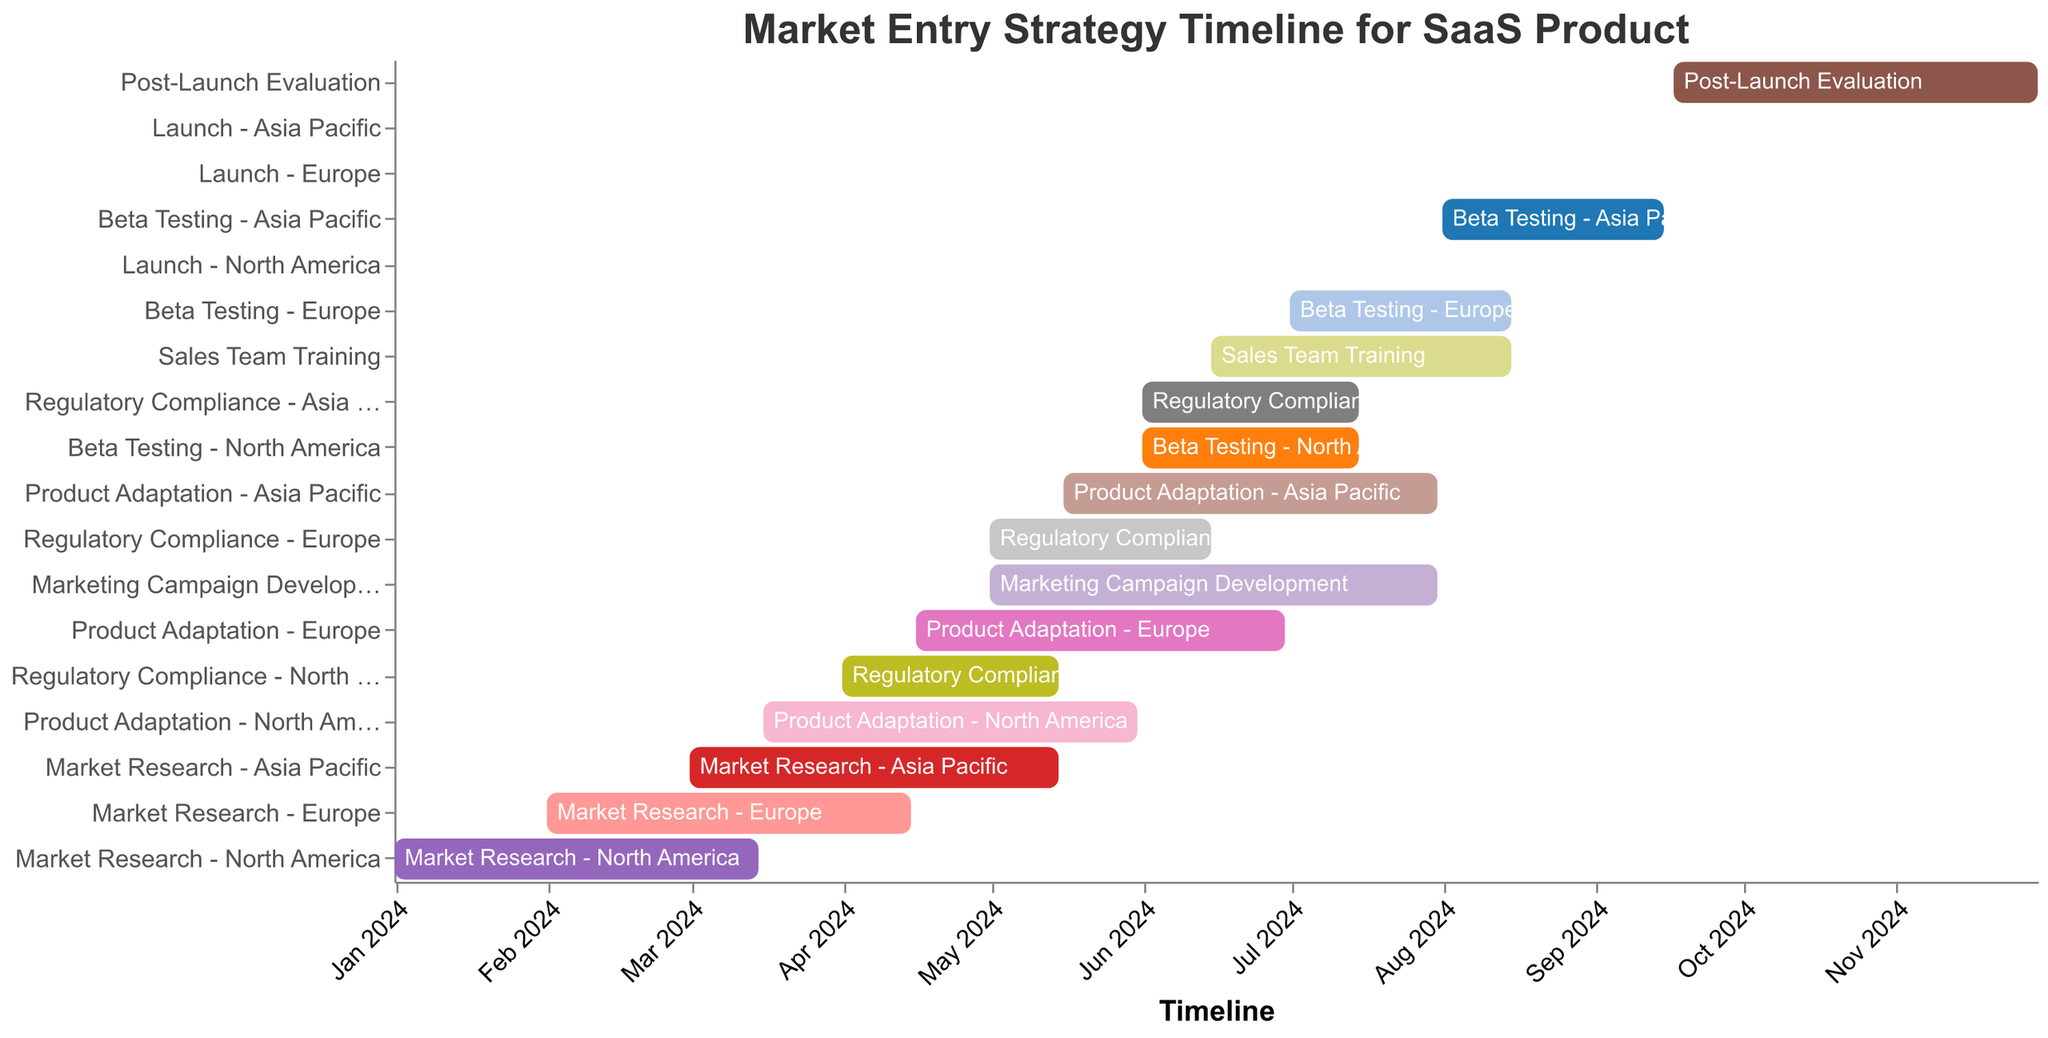What is the title of the Gantt Chart? The title is located at the top of the chart and provides a brief description of what the chart is about.
Answer: Market Entry Strategy Timeline for SaaS Product Which phase starts first in the timeline? To determine which phase starts first, look for the earliest "Start Date" on the timeline.
Answer: Market Research - North America How long does the "Product Adaptation - North America" phase last? Subtract the "Start Date" from the "End Date" for the "Product Adaptation - North America" task to calculate its duration. A simple date difference calculation will provide the duration.
Answer: 76 days Which market completes its "Beta Testing" phase last? Compare the "End Date" of the "Beta Testing" phase for North America, Europe, and Asia Pacific. The market with the latest "End Date" finishes last.
Answer: Asia Pacific During which month does the "Sales Team Training" start? Check the "Start Date" of the "Sales Team Training" task to identify the starting month.
Answer: June 2024 What task is executed immediately after "Marketing Campaign Development"? Look at the "End Date" of "Marketing Campaign Development" and identify the next task that starts after this date.
Answer: Sales Team Training Which country has its "Product Adaptation" phase overlap with its "Regulatory Compliance" phase? Identify the countries with overlapping dates by comparing the start and end dates of their "Product Adaptation" and "Regulatory Compliance" phases.
Answer: North America For how many months does the "Post-Launch Evaluation" phase run? Calculate the time span between the "Start Date" and "End Date" for the "Post-Launch Evaluation" phase, then convert the duration into months.
Answer: 2.5 months What are the total number of tasks listed in the Gantt Chart? Count the number of unique tasks listed on the Y-axis of the chart.
Answer: 18 tasks Which phase is the last in the timeline? Look for the task with the latest "End Date" on the timeline.
Answer: Post-Launch Evaluation 